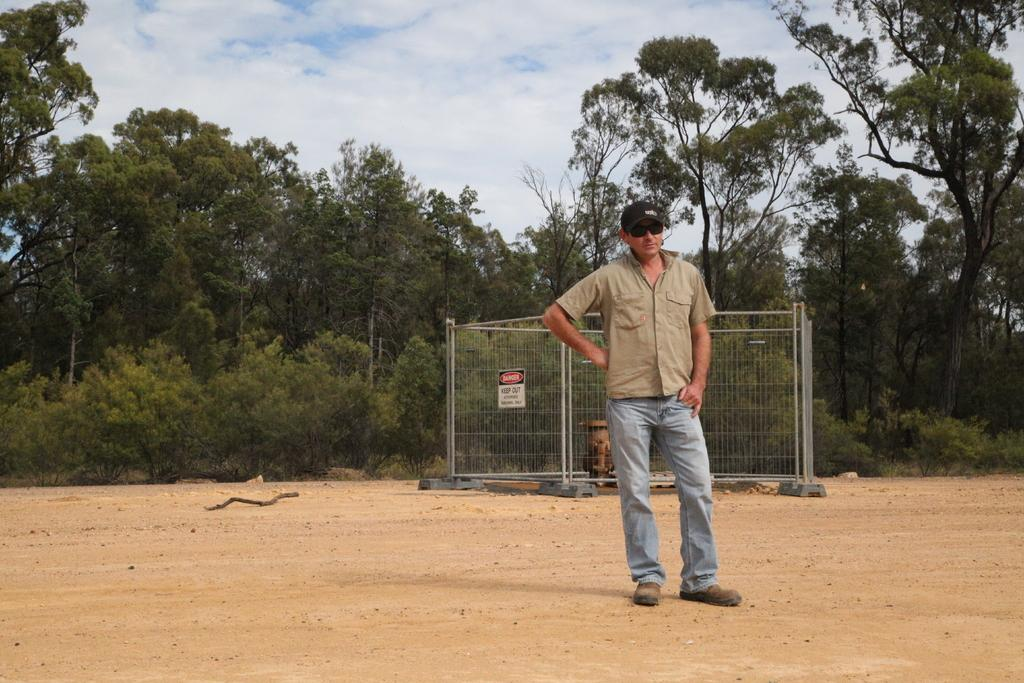Who or what is the main subject in the image? There is a person in the image. What is the person interacting with or near in the image? There is a fence in the image, and the person may be interacting with it. What else can be seen in the image besides the person and the fence? There are other objects in the image, as well as trees and the sky in the background, and the ground at the bottom of the image. What songs can be heard playing from the store in the image? There is no store present in the image, so no songs can be heard playing from it. 